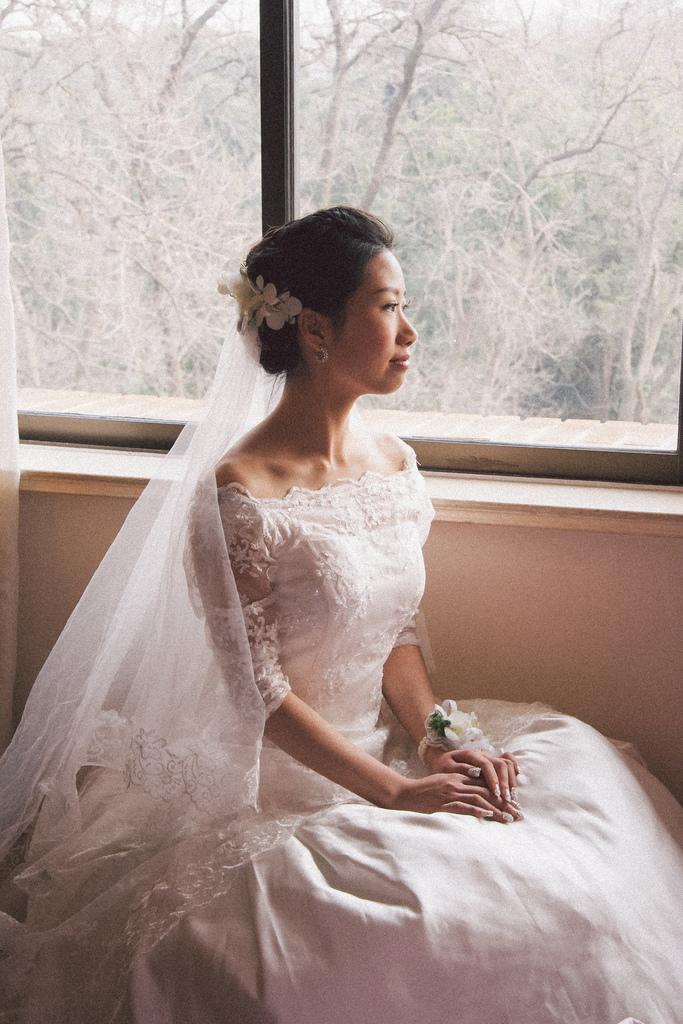Who is present in the image? There is a woman in the image. What is the woman wearing? The woman is wearing a white dress. What can be seen behind the woman? There is a window behind the woman. What is visible in the background of the image? Trees are visible in the background of the image. Reasoning: Let's think step by following the guidelines to produce the conversation. We start by identifying the main subject in the image, which is the woman. Then, we describe her clothing, the window behind her, and the trees visible in the background. Each question is designed to elicit a specific detail about the image that is known from the provided facts. Absurd Question/Answer: What month is depicted in the image? There is no indication of a specific month in the image. Can you see a tiger in the image? No, there is no tiger present in the image. What type of soap is the woman using in the image? There is no soap present in the image. Can you see a tiger in the image? No, there is no tiger present in the image. 